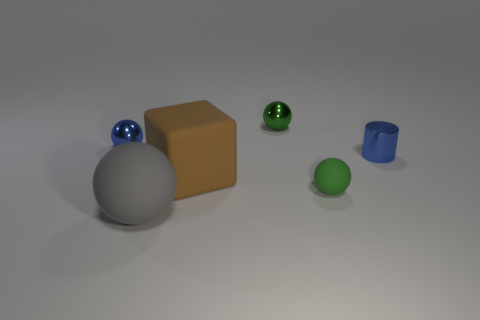Subtract all blue spheres. How many spheres are left? 3 Add 4 green shiny spheres. How many objects exist? 10 Subtract all blue spheres. How many spheres are left? 3 Subtract all cubes. How many objects are left? 5 Subtract 1 cylinders. How many cylinders are left? 0 Subtract all green matte things. Subtract all cylinders. How many objects are left? 4 Add 5 small green matte balls. How many small green matte balls are left? 6 Add 4 tiny things. How many tiny things exist? 8 Subtract 1 blue cylinders. How many objects are left? 5 Subtract all purple balls. Subtract all purple cylinders. How many balls are left? 4 